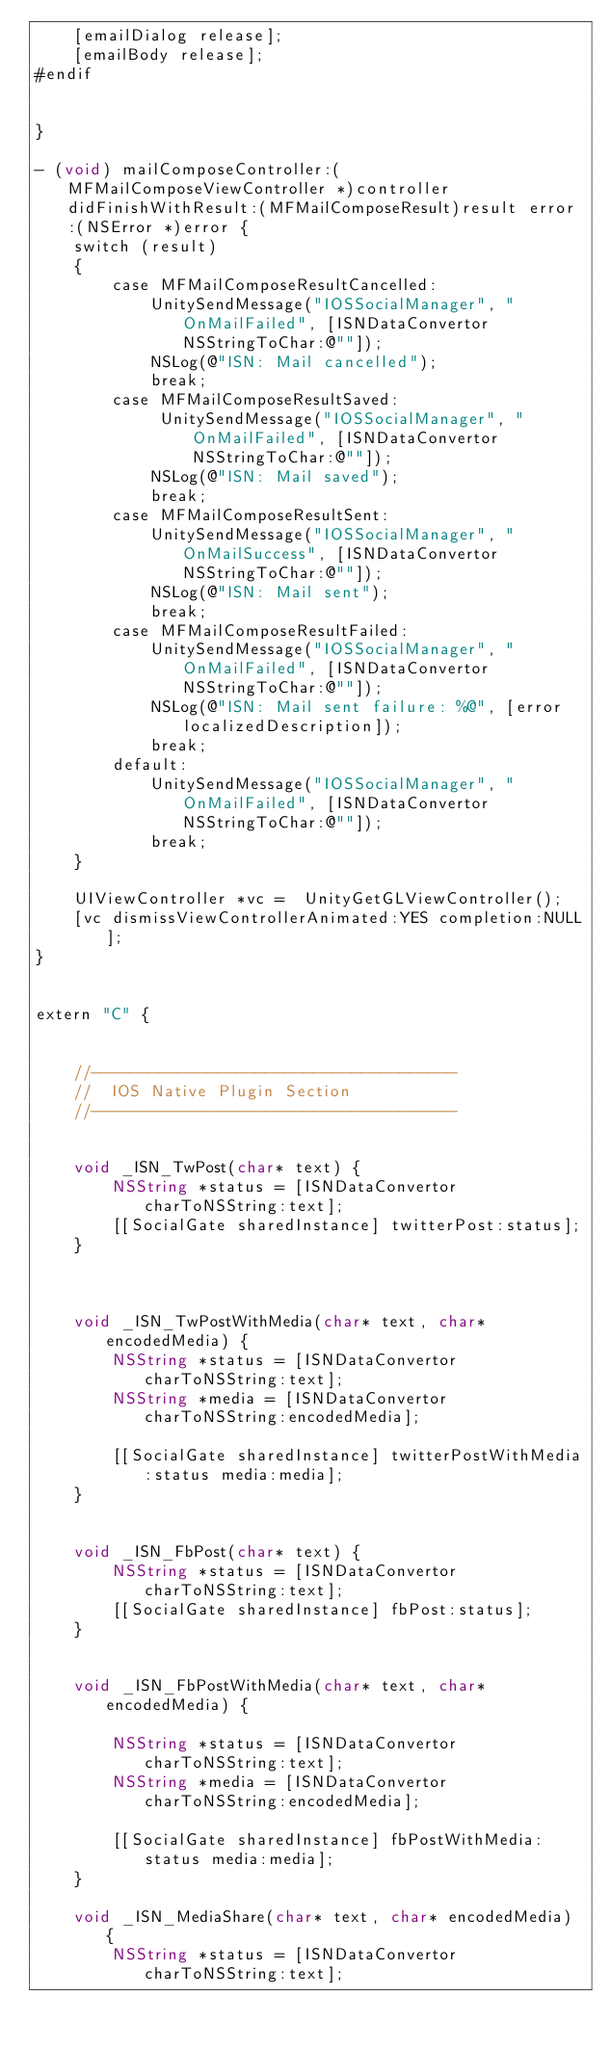<code> <loc_0><loc_0><loc_500><loc_500><_ObjectiveC_>    [emailDialog release];
    [emailBody release];
#endif
    
    
}

- (void) mailComposeController:(MFMailComposeViewController *)controller didFinishWithResult:(MFMailComposeResult)result error:(NSError *)error {
    switch (result)
    {
        case MFMailComposeResultCancelled:
            UnitySendMessage("IOSSocialManager", "OnMailFailed", [ISNDataConvertor NSStringToChar:@""]);
            NSLog(@"ISN: Mail cancelled");
            break;
        case MFMailComposeResultSaved:
             UnitySendMessage("IOSSocialManager", "OnMailFailed", [ISNDataConvertor NSStringToChar:@""]);
            NSLog(@"ISN: Mail saved");
            break;
        case MFMailComposeResultSent:
            UnitySendMessage("IOSSocialManager", "OnMailSuccess", [ISNDataConvertor NSStringToChar:@""]);
            NSLog(@"ISN: Mail sent");
            break;
        case MFMailComposeResultFailed:
            UnitySendMessage("IOSSocialManager", "OnMailFailed", [ISNDataConvertor NSStringToChar:@""]);
            NSLog(@"ISN: Mail sent failure: %@", [error localizedDescription]);
            break;
        default:
            UnitySendMessage("IOSSocialManager", "OnMailFailed", [ISNDataConvertor NSStringToChar:@""]);
            break;
    }
    
    UIViewController *vc =  UnityGetGLViewController();
    [vc dismissViewControllerAnimated:YES completion:NULL];
}


extern "C" {
    
    
    //--------------------------------------
	//  IOS Native Plugin Section
	//--------------------------------------
    
    
    void _ISN_TwPost(char* text) {
        NSString *status = [ISNDataConvertor charToNSString:text];
        [[SocialGate sharedInstance] twitterPost:status];
    }
    
    
    
    void _ISN_TwPostWithMedia(char* text, char* encodedMedia) {
        NSString *status = [ISNDataConvertor charToNSString:text];
        NSString *media = [ISNDataConvertor charToNSString:encodedMedia];
        
        [[SocialGate sharedInstance] twitterPostWithMedia:status media:media];
    }
    
    
    void _ISN_FbPost(char* text) {
        NSString *status = [ISNDataConvertor charToNSString:text];
        [[SocialGate sharedInstance] fbPost:status];
    }
    
    
    void _ISN_FbPostWithMedia(char* text, char* encodedMedia) {
        
        NSString *status = [ISNDataConvertor charToNSString:text];
        NSString *media = [ISNDataConvertor charToNSString:encodedMedia];
        
        [[SocialGate sharedInstance] fbPostWithMedia:status media:media];
    }
    
    void _ISN_MediaShare(char* text, char* encodedMedia) {
        NSString *status = [ISNDataConvertor charToNSString:text];</code> 